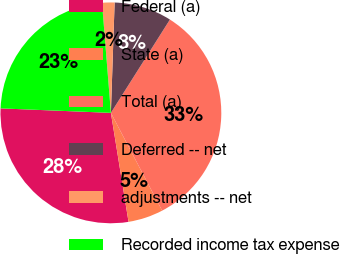<chart> <loc_0><loc_0><loc_500><loc_500><pie_chart><fcel>Federal (a)<fcel>State (a)<fcel>Total (a)<fcel>Deferred -- net<fcel>adjustments -- net<fcel>Recorded income tax expense<nl><fcel>28.2%<fcel>5.13%<fcel>33.33%<fcel>8.44%<fcel>1.82%<fcel>23.07%<nl></chart> 